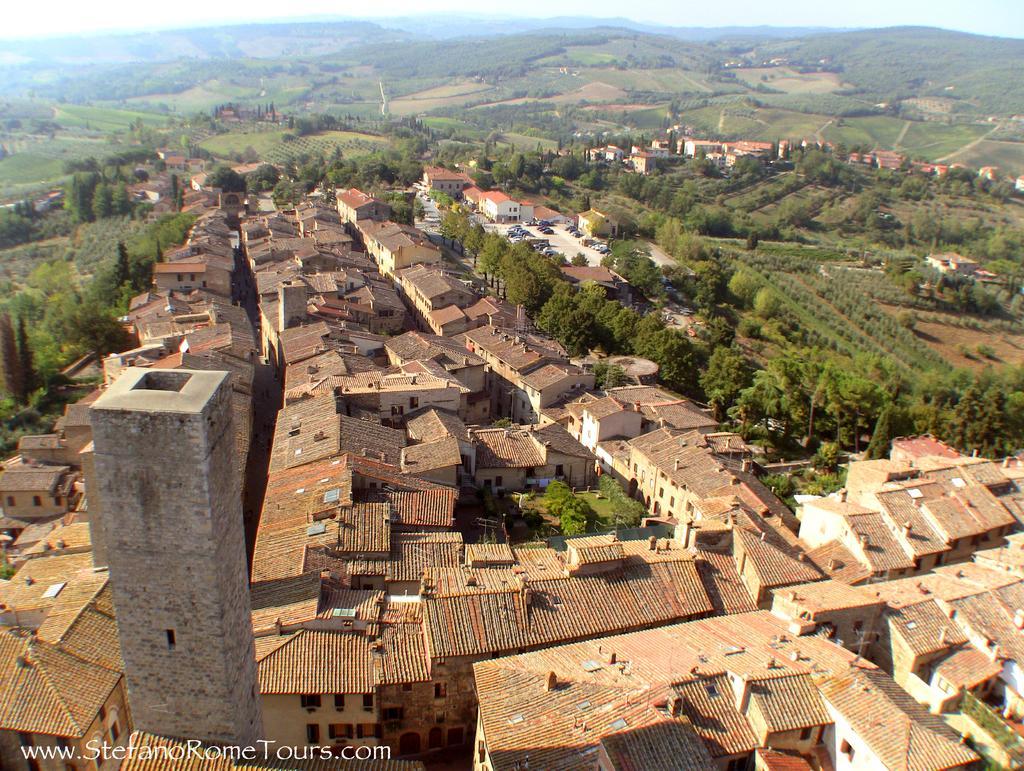In one or two sentences, can you explain what this image depicts? In this picture we can see so many buildings, trees and hills. 